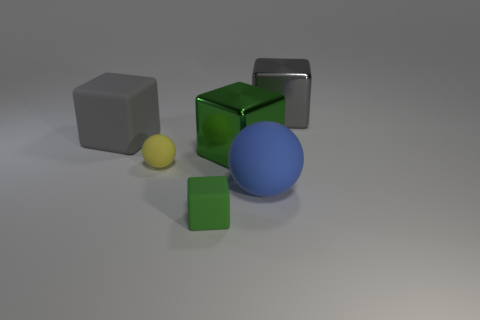There is a cube that is behind the matte cube behind the large ball; what is its color?
Give a very brief answer. Gray. There is another cube that is made of the same material as the small green cube; what is its color?
Provide a short and direct response. Gray. How many big rubber cubes have the same color as the tiny cube?
Offer a terse response. 0. What number of objects are either big green metallic things or green rubber things?
Your response must be concise. 2. The blue rubber thing that is the same size as the gray rubber object is what shape?
Your answer should be compact. Sphere. What number of things are in front of the large gray rubber object and on the right side of the yellow object?
Your answer should be very brief. 3. What is the small yellow sphere on the right side of the big gray rubber thing made of?
Ensure brevity in your answer.  Rubber. What size is the gray object that is the same material as the blue sphere?
Ensure brevity in your answer.  Large. There is a block that is in front of the big blue sphere; is it the same size as the sphere to the left of the big green thing?
Keep it short and to the point. Yes. What is the material of the green thing that is the same size as the yellow rubber thing?
Your answer should be compact. Rubber. 